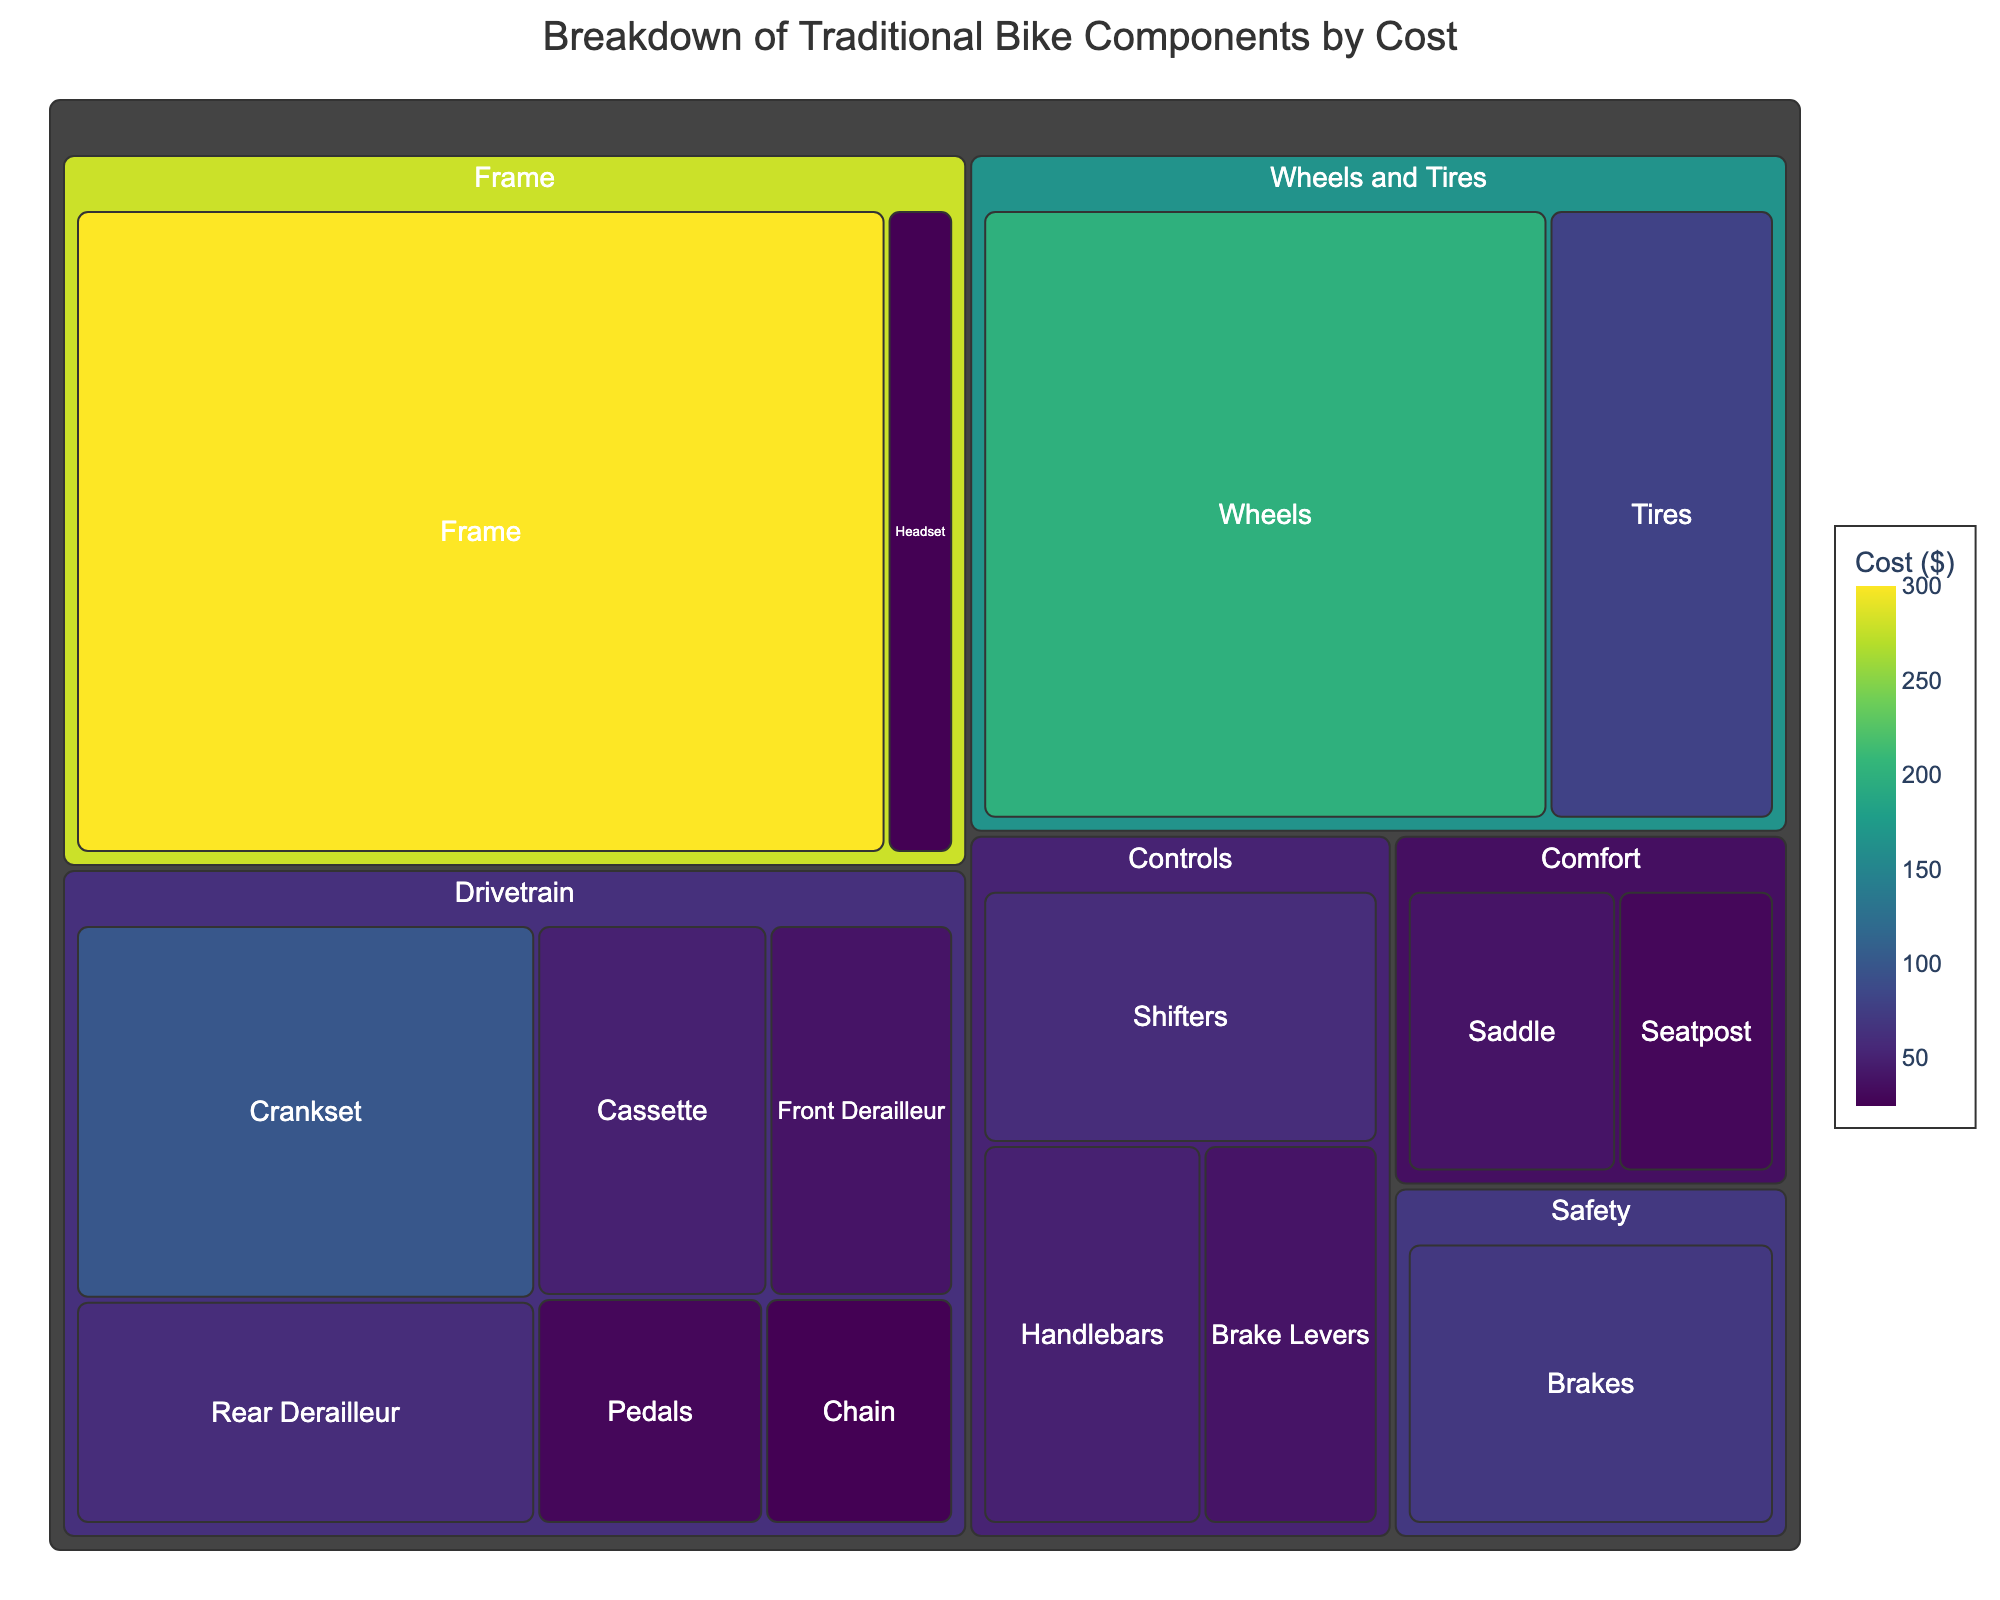what is the most expensive component? The most expensive component in the treemap is "Frame," indicated by its large tile size and the highest cost value of $300 displayed.
Answer: Frame what is the total cost of components within the Wheel and Tires category? The cost of Wheels is $200 and the cost of Tires is $80, so the total cost for the Wheel and Tires category is $200 + $80 = $280
Answer: $280 Which category has the lowest total cost? By visually comparing the tile sizes and cost values in each category, "Comfort" has the lowest overall total cost, with Saddle at $40 and Seatpost at $30, summing up to $70
Answer: Comfort Which components fall under the "Drivetrain" category? By examining the treemap and the various components within the "Drivetrain" category, the components include Pedals, Chain, Crankset, Rear Derailleur, Front Derailleur, and Cassette
Answer: Pedals, Chain, Crankset, Rear Derailleur, Front Derailleur, Cassette What is the cost difference between the "Frame" and "Brakes"? The "Frame" has a cost of $300 and the "Brakes" have a cost of $70. Therefore, the cost difference is $300 - $70 = $230
Answer: $230 Which component under the "Controls" category is the most expensive? By examining the "Controls" category within the treemap, the "Shifters" are the most expensive component, with a cost of $60.
Answer: Shifters How many categories have components costing more than $100? Frame has one component costing $300, "Wheels and Tires" has Wheels costing $200, and "Drivetrain" has a Crankset costing $100. So, there are three categories with at least one component costing more than $100.
Answer: 3 What is the combined cost of the "Pedals" and "Brakes"? The cost of Pedals is $30 and the cost of Brakes is $70. Therefore, the combined cost is $30 + $70 = $100
Answer: $100 